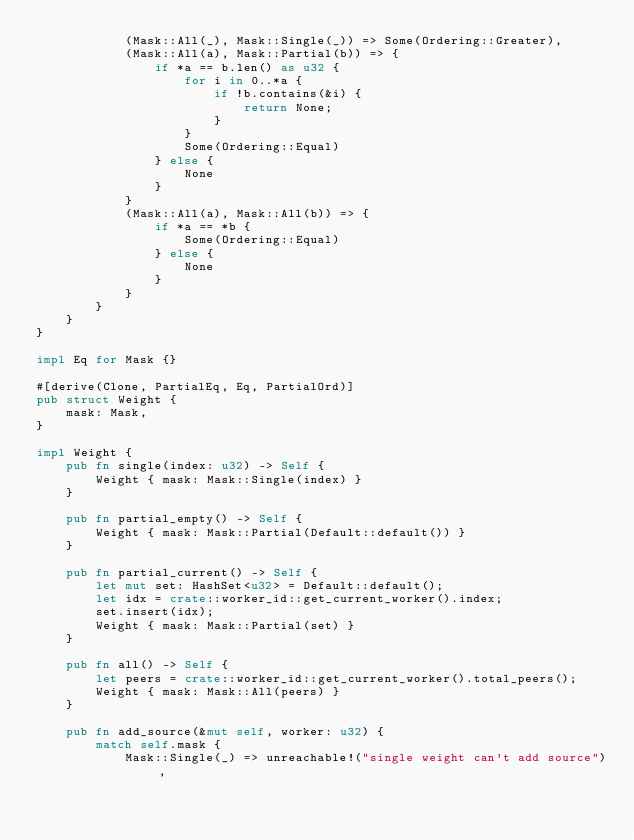Convert code to text. <code><loc_0><loc_0><loc_500><loc_500><_Rust_>            (Mask::All(_), Mask::Single(_)) => Some(Ordering::Greater),
            (Mask::All(a), Mask::Partial(b)) => {
                if *a == b.len() as u32 {
                    for i in 0..*a {
                        if !b.contains(&i) {
                            return None;
                        }
                    }
                    Some(Ordering::Equal)
                } else {
                    None
                }
            }
            (Mask::All(a), Mask::All(b)) => {
                if *a == *b {
                    Some(Ordering::Equal)
                } else {
                    None
                }
            }
        }
    }
}

impl Eq for Mask {}

#[derive(Clone, PartialEq, Eq, PartialOrd)]
pub struct Weight {
    mask: Mask,
}

impl Weight {
    pub fn single(index: u32) -> Self {
        Weight { mask: Mask::Single(index) }
    }

    pub fn partial_empty() -> Self {
        Weight { mask: Mask::Partial(Default::default()) }
    }

    pub fn partial_current() -> Self {
        let mut set: HashSet<u32> = Default::default();
        let idx = crate::worker_id::get_current_worker().index;
        set.insert(idx);
        Weight { mask: Mask::Partial(set) }
    }

    pub fn all() -> Self {
        let peers = crate::worker_id::get_current_worker().total_peers();
        Weight { mask: Mask::All(peers) }
    }

    pub fn add_source(&mut self, worker: u32) {
        match self.mask {
            Mask::Single(_) => unreachable!("single weight can't add source"),</code> 